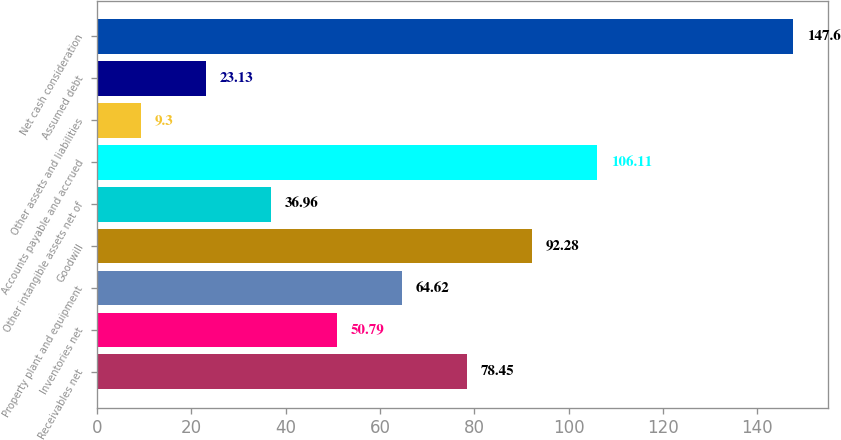Convert chart to OTSL. <chart><loc_0><loc_0><loc_500><loc_500><bar_chart><fcel>Receivables net<fcel>Inventories net<fcel>Property plant and equipment<fcel>Goodwill<fcel>Other intangible assets net of<fcel>Accounts payable and accrued<fcel>Other assets and liabilities<fcel>Assumed debt<fcel>Net cash consideration<nl><fcel>78.45<fcel>50.79<fcel>64.62<fcel>92.28<fcel>36.96<fcel>106.11<fcel>9.3<fcel>23.13<fcel>147.6<nl></chart> 